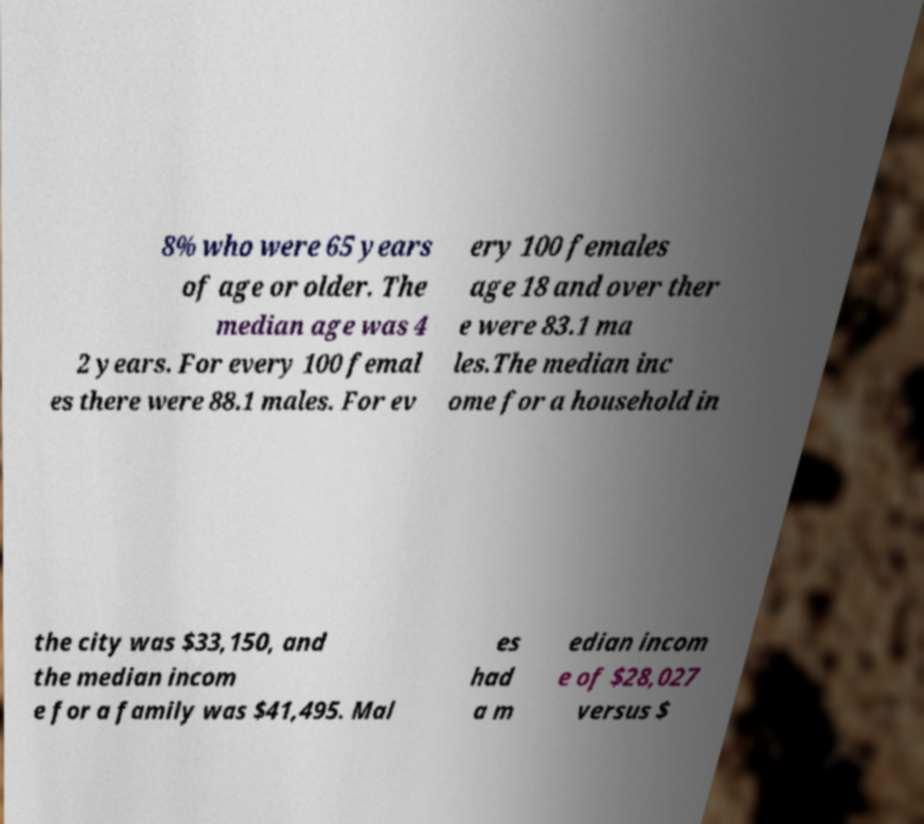For documentation purposes, I need the text within this image transcribed. Could you provide that? 8% who were 65 years of age or older. The median age was 4 2 years. For every 100 femal es there were 88.1 males. For ev ery 100 females age 18 and over ther e were 83.1 ma les.The median inc ome for a household in the city was $33,150, and the median incom e for a family was $41,495. Mal es had a m edian incom e of $28,027 versus $ 